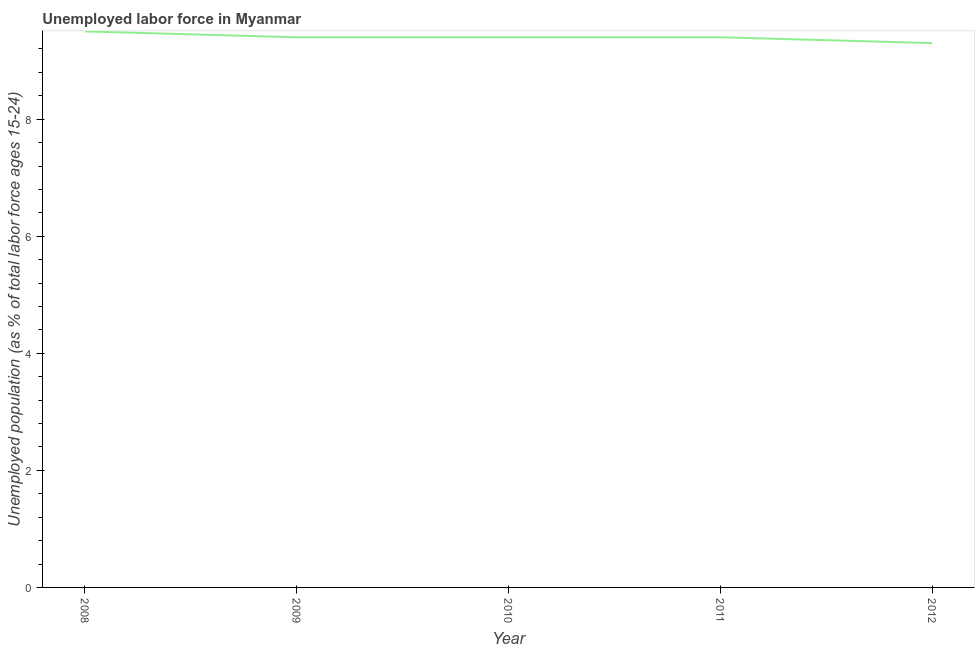What is the total unemployed youth population in 2011?
Ensure brevity in your answer.  9.4. Across all years, what is the maximum total unemployed youth population?
Give a very brief answer. 9.5. Across all years, what is the minimum total unemployed youth population?
Your response must be concise. 9.3. In which year was the total unemployed youth population maximum?
Provide a succinct answer. 2008. In which year was the total unemployed youth population minimum?
Your response must be concise. 2012. What is the sum of the total unemployed youth population?
Your answer should be very brief. 47. What is the difference between the total unemployed youth population in 2008 and 2012?
Make the answer very short. 0.2. What is the average total unemployed youth population per year?
Your answer should be compact. 9.4. What is the median total unemployed youth population?
Provide a succinct answer. 9.4. In how many years, is the total unemployed youth population greater than 1.6 %?
Provide a succinct answer. 5. Do a majority of the years between 2009 and 2011 (inclusive) have total unemployed youth population greater than 7.2 %?
Provide a succinct answer. Yes. What is the ratio of the total unemployed youth population in 2008 to that in 2011?
Ensure brevity in your answer.  1.01. Is the total unemployed youth population in 2008 less than that in 2009?
Your answer should be compact. No. What is the difference between the highest and the second highest total unemployed youth population?
Keep it short and to the point. 0.1. Is the sum of the total unemployed youth population in 2009 and 2012 greater than the maximum total unemployed youth population across all years?
Your answer should be very brief. Yes. What is the difference between the highest and the lowest total unemployed youth population?
Offer a very short reply. 0.2. In how many years, is the total unemployed youth population greater than the average total unemployed youth population taken over all years?
Offer a very short reply. 1. How many years are there in the graph?
Keep it short and to the point. 5. What is the difference between two consecutive major ticks on the Y-axis?
Offer a very short reply. 2. Are the values on the major ticks of Y-axis written in scientific E-notation?
Give a very brief answer. No. Does the graph contain any zero values?
Make the answer very short. No. Does the graph contain grids?
Your answer should be very brief. No. What is the title of the graph?
Provide a succinct answer. Unemployed labor force in Myanmar. What is the label or title of the X-axis?
Ensure brevity in your answer.  Year. What is the label or title of the Y-axis?
Offer a very short reply. Unemployed population (as % of total labor force ages 15-24). What is the Unemployed population (as % of total labor force ages 15-24) in 2008?
Your answer should be very brief. 9.5. What is the Unemployed population (as % of total labor force ages 15-24) in 2009?
Your response must be concise. 9.4. What is the Unemployed population (as % of total labor force ages 15-24) of 2010?
Make the answer very short. 9.4. What is the Unemployed population (as % of total labor force ages 15-24) in 2011?
Offer a very short reply. 9.4. What is the Unemployed population (as % of total labor force ages 15-24) in 2012?
Keep it short and to the point. 9.3. What is the difference between the Unemployed population (as % of total labor force ages 15-24) in 2008 and 2010?
Ensure brevity in your answer.  0.1. What is the difference between the Unemployed population (as % of total labor force ages 15-24) in 2008 and 2012?
Ensure brevity in your answer.  0.2. What is the difference between the Unemployed population (as % of total labor force ages 15-24) in 2009 and 2012?
Your response must be concise. 0.1. What is the difference between the Unemployed population (as % of total labor force ages 15-24) in 2010 and 2011?
Provide a succinct answer. 0. What is the difference between the Unemployed population (as % of total labor force ages 15-24) in 2011 and 2012?
Ensure brevity in your answer.  0.1. What is the ratio of the Unemployed population (as % of total labor force ages 15-24) in 2008 to that in 2011?
Offer a very short reply. 1.01. What is the ratio of the Unemployed population (as % of total labor force ages 15-24) in 2009 to that in 2010?
Make the answer very short. 1. What is the ratio of the Unemployed population (as % of total labor force ages 15-24) in 2009 to that in 2012?
Provide a short and direct response. 1.01. What is the ratio of the Unemployed population (as % of total labor force ages 15-24) in 2010 to that in 2011?
Offer a very short reply. 1. What is the ratio of the Unemployed population (as % of total labor force ages 15-24) in 2010 to that in 2012?
Make the answer very short. 1.01. What is the ratio of the Unemployed population (as % of total labor force ages 15-24) in 2011 to that in 2012?
Keep it short and to the point. 1.01. 